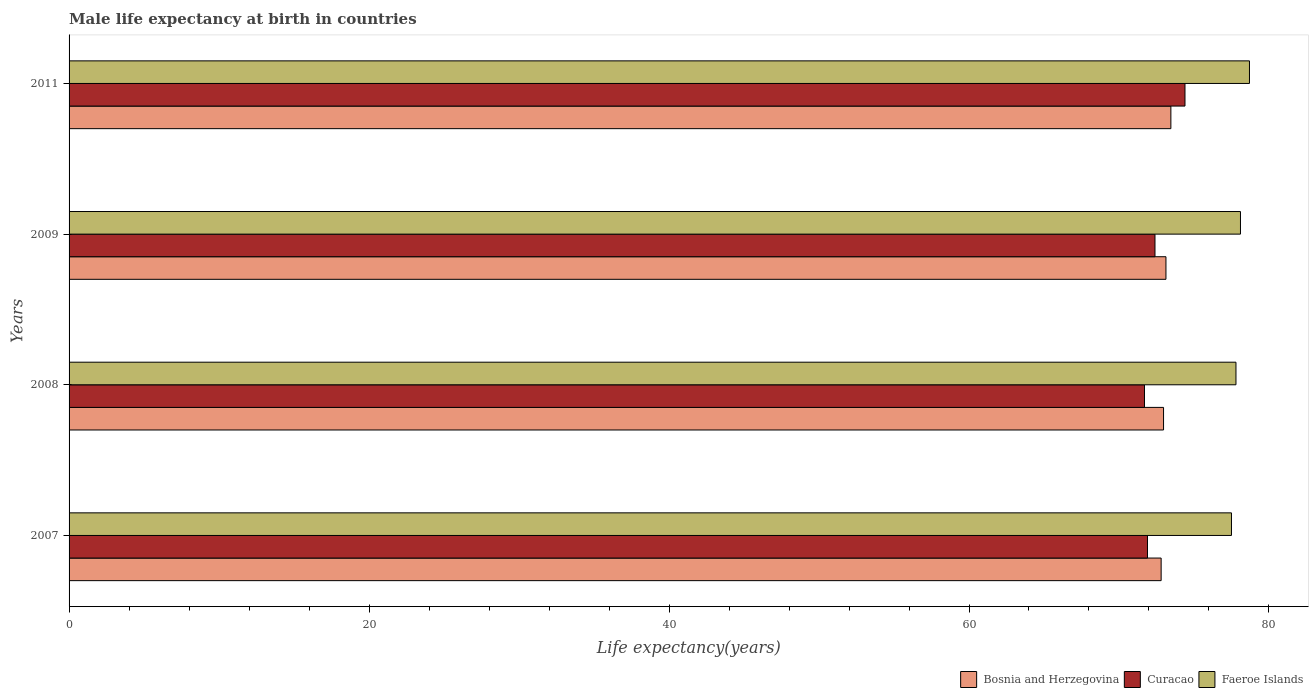Are the number of bars on each tick of the Y-axis equal?
Keep it short and to the point. Yes. How many bars are there on the 1st tick from the top?
Provide a succinct answer. 3. How many bars are there on the 3rd tick from the bottom?
Your answer should be compact. 3. What is the male life expectancy at birth in Curacao in 2011?
Keep it short and to the point. 74.4. Across all years, what is the maximum male life expectancy at birth in Bosnia and Herzegovina?
Your response must be concise. 73.46. Across all years, what is the minimum male life expectancy at birth in Bosnia and Herzegovina?
Your response must be concise. 72.81. What is the total male life expectancy at birth in Bosnia and Herzegovina in the graph?
Offer a terse response. 292.37. What is the difference between the male life expectancy at birth in Faeroe Islands in 2007 and that in 2011?
Provide a short and direct response. -1.2. What is the difference between the male life expectancy at birth in Bosnia and Herzegovina in 2009 and the male life expectancy at birth in Faeroe Islands in 2011?
Make the answer very short. -5.57. What is the average male life expectancy at birth in Curacao per year?
Your response must be concise. 72.6. In the year 2009, what is the difference between the male life expectancy at birth in Curacao and male life expectancy at birth in Bosnia and Herzegovina?
Offer a very short reply. -0.73. In how many years, is the male life expectancy at birth in Bosnia and Herzegovina greater than 68 years?
Keep it short and to the point. 4. What is the ratio of the male life expectancy at birth in Bosnia and Herzegovina in 2008 to that in 2011?
Offer a terse response. 0.99. What is the difference between the highest and the second highest male life expectancy at birth in Bosnia and Herzegovina?
Your response must be concise. 0.33. What is the difference between the highest and the lowest male life expectancy at birth in Faeroe Islands?
Offer a terse response. 1.2. In how many years, is the male life expectancy at birth in Faeroe Islands greater than the average male life expectancy at birth in Faeroe Islands taken over all years?
Offer a very short reply. 2. Is the sum of the male life expectancy at birth in Faeroe Islands in 2008 and 2011 greater than the maximum male life expectancy at birth in Curacao across all years?
Provide a short and direct response. Yes. What does the 3rd bar from the top in 2008 represents?
Provide a short and direct response. Bosnia and Herzegovina. What does the 1st bar from the bottom in 2011 represents?
Keep it short and to the point. Bosnia and Herzegovina. How many years are there in the graph?
Offer a terse response. 4. What is the difference between two consecutive major ticks on the X-axis?
Keep it short and to the point. 20. Does the graph contain any zero values?
Make the answer very short. No. Where does the legend appear in the graph?
Keep it short and to the point. Bottom right. How are the legend labels stacked?
Your answer should be very brief. Horizontal. What is the title of the graph?
Your answer should be very brief. Male life expectancy at birth in countries. Does "Djibouti" appear as one of the legend labels in the graph?
Make the answer very short. No. What is the label or title of the X-axis?
Provide a succinct answer. Life expectancy(years). What is the label or title of the Y-axis?
Ensure brevity in your answer.  Years. What is the Life expectancy(years) in Bosnia and Herzegovina in 2007?
Offer a terse response. 72.81. What is the Life expectancy(years) of Curacao in 2007?
Your response must be concise. 71.9. What is the Life expectancy(years) in Faeroe Islands in 2007?
Offer a terse response. 77.5. What is the Life expectancy(years) of Bosnia and Herzegovina in 2008?
Make the answer very short. 72.97. What is the Life expectancy(years) in Curacao in 2008?
Keep it short and to the point. 71.7. What is the Life expectancy(years) of Faeroe Islands in 2008?
Offer a terse response. 77.8. What is the Life expectancy(years) in Bosnia and Herzegovina in 2009?
Your answer should be compact. 73.13. What is the Life expectancy(years) in Curacao in 2009?
Ensure brevity in your answer.  72.4. What is the Life expectancy(years) in Faeroe Islands in 2009?
Offer a terse response. 78.1. What is the Life expectancy(years) in Bosnia and Herzegovina in 2011?
Provide a succinct answer. 73.46. What is the Life expectancy(years) of Curacao in 2011?
Offer a very short reply. 74.4. What is the Life expectancy(years) of Faeroe Islands in 2011?
Your answer should be compact. 78.7. Across all years, what is the maximum Life expectancy(years) of Bosnia and Herzegovina?
Offer a terse response. 73.46. Across all years, what is the maximum Life expectancy(years) of Curacao?
Offer a very short reply. 74.4. Across all years, what is the maximum Life expectancy(years) of Faeroe Islands?
Make the answer very short. 78.7. Across all years, what is the minimum Life expectancy(years) of Bosnia and Herzegovina?
Give a very brief answer. 72.81. Across all years, what is the minimum Life expectancy(years) of Curacao?
Offer a terse response. 71.7. Across all years, what is the minimum Life expectancy(years) of Faeroe Islands?
Your answer should be compact. 77.5. What is the total Life expectancy(years) of Bosnia and Herzegovina in the graph?
Your answer should be very brief. 292.37. What is the total Life expectancy(years) in Curacao in the graph?
Offer a very short reply. 290.4. What is the total Life expectancy(years) of Faeroe Islands in the graph?
Keep it short and to the point. 312.1. What is the difference between the Life expectancy(years) of Bosnia and Herzegovina in 2007 and that in 2008?
Offer a terse response. -0.16. What is the difference between the Life expectancy(years) of Curacao in 2007 and that in 2008?
Make the answer very short. 0.2. What is the difference between the Life expectancy(years) in Bosnia and Herzegovina in 2007 and that in 2009?
Ensure brevity in your answer.  -0.32. What is the difference between the Life expectancy(years) of Curacao in 2007 and that in 2009?
Keep it short and to the point. -0.5. What is the difference between the Life expectancy(years) of Bosnia and Herzegovina in 2007 and that in 2011?
Ensure brevity in your answer.  -0.65. What is the difference between the Life expectancy(years) in Curacao in 2007 and that in 2011?
Your answer should be very brief. -2.5. What is the difference between the Life expectancy(years) of Bosnia and Herzegovina in 2008 and that in 2009?
Your response must be concise. -0.16. What is the difference between the Life expectancy(years) in Bosnia and Herzegovina in 2008 and that in 2011?
Your answer should be very brief. -0.49. What is the difference between the Life expectancy(years) of Bosnia and Herzegovina in 2009 and that in 2011?
Your answer should be very brief. -0.33. What is the difference between the Life expectancy(years) of Faeroe Islands in 2009 and that in 2011?
Offer a terse response. -0.6. What is the difference between the Life expectancy(years) of Bosnia and Herzegovina in 2007 and the Life expectancy(years) of Curacao in 2008?
Provide a short and direct response. 1.11. What is the difference between the Life expectancy(years) of Bosnia and Herzegovina in 2007 and the Life expectancy(years) of Faeroe Islands in 2008?
Keep it short and to the point. -4.99. What is the difference between the Life expectancy(years) in Bosnia and Herzegovina in 2007 and the Life expectancy(years) in Curacao in 2009?
Your response must be concise. 0.41. What is the difference between the Life expectancy(years) of Bosnia and Herzegovina in 2007 and the Life expectancy(years) of Faeroe Islands in 2009?
Keep it short and to the point. -5.29. What is the difference between the Life expectancy(years) in Bosnia and Herzegovina in 2007 and the Life expectancy(years) in Curacao in 2011?
Your answer should be compact. -1.59. What is the difference between the Life expectancy(years) of Bosnia and Herzegovina in 2007 and the Life expectancy(years) of Faeroe Islands in 2011?
Provide a succinct answer. -5.89. What is the difference between the Life expectancy(years) in Curacao in 2007 and the Life expectancy(years) in Faeroe Islands in 2011?
Your answer should be compact. -6.8. What is the difference between the Life expectancy(years) of Bosnia and Herzegovina in 2008 and the Life expectancy(years) of Curacao in 2009?
Your answer should be compact. 0.57. What is the difference between the Life expectancy(years) in Bosnia and Herzegovina in 2008 and the Life expectancy(years) in Faeroe Islands in 2009?
Keep it short and to the point. -5.13. What is the difference between the Life expectancy(years) in Curacao in 2008 and the Life expectancy(years) in Faeroe Islands in 2009?
Your response must be concise. -6.4. What is the difference between the Life expectancy(years) in Bosnia and Herzegovina in 2008 and the Life expectancy(years) in Curacao in 2011?
Your answer should be very brief. -1.43. What is the difference between the Life expectancy(years) of Bosnia and Herzegovina in 2008 and the Life expectancy(years) of Faeroe Islands in 2011?
Provide a succinct answer. -5.73. What is the difference between the Life expectancy(years) of Curacao in 2008 and the Life expectancy(years) of Faeroe Islands in 2011?
Your answer should be very brief. -7. What is the difference between the Life expectancy(years) of Bosnia and Herzegovina in 2009 and the Life expectancy(years) of Curacao in 2011?
Offer a very short reply. -1.27. What is the difference between the Life expectancy(years) in Bosnia and Herzegovina in 2009 and the Life expectancy(years) in Faeroe Islands in 2011?
Provide a succinct answer. -5.57. What is the average Life expectancy(years) in Bosnia and Herzegovina per year?
Offer a terse response. 73.09. What is the average Life expectancy(years) in Curacao per year?
Offer a terse response. 72.6. What is the average Life expectancy(years) of Faeroe Islands per year?
Provide a short and direct response. 78.03. In the year 2007, what is the difference between the Life expectancy(years) of Bosnia and Herzegovina and Life expectancy(years) of Curacao?
Provide a succinct answer. 0.91. In the year 2007, what is the difference between the Life expectancy(years) of Bosnia and Herzegovina and Life expectancy(years) of Faeroe Islands?
Provide a succinct answer. -4.69. In the year 2008, what is the difference between the Life expectancy(years) of Bosnia and Herzegovina and Life expectancy(years) of Curacao?
Your response must be concise. 1.27. In the year 2008, what is the difference between the Life expectancy(years) of Bosnia and Herzegovina and Life expectancy(years) of Faeroe Islands?
Your response must be concise. -4.83. In the year 2008, what is the difference between the Life expectancy(years) of Curacao and Life expectancy(years) of Faeroe Islands?
Give a very brief answer. -6.1. In the year 2009, what is the difference between the Life expectancy(years) in Bosnia and Herzegovina and Life expectancy(years) in Curacao?
Ensure brevity in your answer.  0.73. In the year 2009, what is the difference between the Life expectancy(years) in Bosnia and Herzegovina and Life expectancy(years) in Faeroe Islands?
Offer a very short reply. -4.97. In the year 2009, what is the difference between the Life expectancy(years) in Curacao and Life expectancy(years) in Faeroe Islands?
Ensure brevity in your answer.  -5.7. In the year 2011, what is the difference between the Life expectancy(years) in Bosnia and Herzegovina and Life expectancy(years) in Curacao?
Your response must be concise. -0.94. In the year 2011, what is the difference between the Life expectancy(years) of Bosnia and Herzegovina and Life expectancy(years) of Faeroe Islands?
Offer a terse response. -5.24. What is the ratio of the Life expectancy(years) of Curacao in 2007 to that in 2008?
Make the answer very short. 1. What is the ratio of the Life expectancy(years) in Bosnia and Herzegovina in 2007 to that in 2009?
Offer a terse response. 1. What is the ratio of the Life expectancy(years) in Curacao in 2007 to that in 2009?
Provide a succinct answer. 0.99. What is the ratio of the Life expectancy(years) in Bosnia and Herzegovina in 2007 to that in 2011?
Offer a very short reply. 0.99. What is the ratio of the Life expectancy(years) of Curacao in 2007 to that in 2011?
Offer a very short reply. 0.97. What is the ratio of the Life expectancy(years) in Faeroe Islands in 2007 to that in 2011?
Give a very brief answer. 0.98. What is the ratio of the Life expectancy(years) of Bosnia and Herzegovina in 2008 to that in 2009?
Your response must be concise. 1. What is the ratio of the Life expectancy(years) of Curacao in 2008 to that in 2009?
Offer a very short reply. 0.99. What is the ratio of the Life expectancy(years) in Bosnia and Herzegovina in 2008 to that in 2011?
Your answer should be very brief. 0.99. What is the ratio of the Life expectancy(years) in Curacao in 2008 to that in 2011?
Your answer should be very brief. 0.96. What is the ratio of the Life expectancy(years) of Faeroe Islands in 2008 to that in 2011?
Make the answer very short. 0.99. What is the ratio of the Life expectancy(years) of Bosnia and Herzegovina in 2009 to that in 2011?
Ensure brevity in your answer.  1. What is the ratio of the Life expectancy(years) of Curacao in 2009 to that in 2011?
Give a very brief answer. 0.97. What is the difference between the highest and the second highest Life expectancy(years) of Bosnia and Herzegovina?
Make the answer very short. 0.33. What is the difference between the highest and the lowest Life expectancy(years) in Bosnia and Herzegovina?
Offer a very short reply. 0.65. What is the difference between the highest and the lowest Life expectancy(years) in Curacao?
Provide a short and direct response. 2.7. 